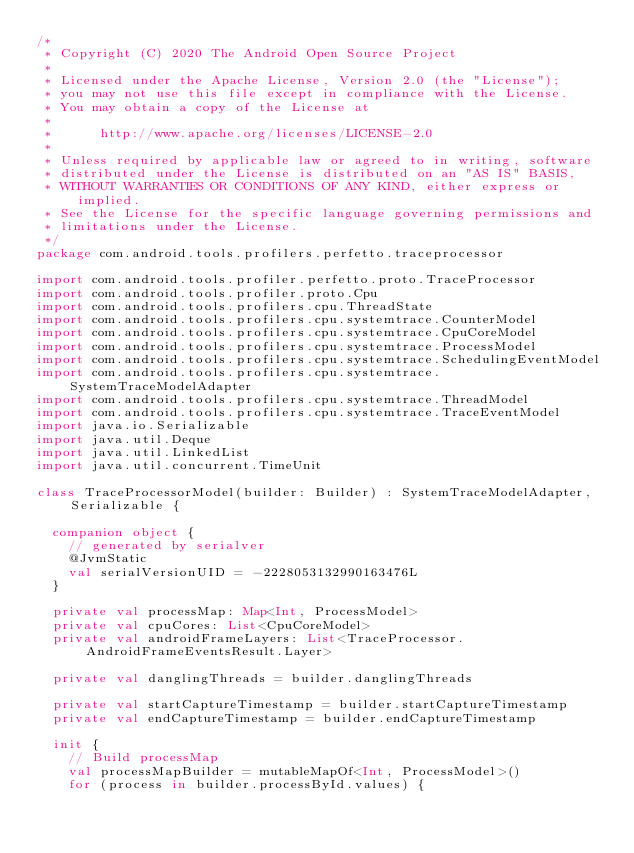<code> <loc_0><loc_0><loc_500><loc_500><_Kotlin_>/*
 * Copyright (C) 2020 The Android Open Source Project
 *
 * Licensed under the Apache License, Version 2.0 (the "License");
 * you may not use this file except in compliance with the License.
 * You may obtain a copy of the License at
 *
 *      http://www.apache.org/licenses/LICENSE-2.0
 *
 * Unless required by applicable law or agreed to in writing, software
 * distributed under the License is distributed on an "AS IS" BASIS,
 * WITHOUT WARRANTIES OR CONDITIONS OF ANY KIND, either express or implied.
 * See the License for the specific language governing permissions and
 * limitations under the License.
 */
package com.android.tools.profilers.perfetto.traceprocessor

import com.android.tools.profiler.perfetto.proto.TraceProcessor
import com.android.tools.profiler.proto.Cpu
import com.android.tools.profilers.cpu.ThreadState
import com.android.tools.profilers.cpu.systemtrace.CounterModel
import com.android.tools.profilers.cpu.systemtrace.CpuCoreModel
import com.android.tools.profilers.cpu.systemtrace.ProcessModel
import com.android.tools.profilers.cpu.systemtrace.SchedulingEventModel
import com.android.tools.profilers.cpu.systemtrace.SystemTraceModelAdapter
import com.android.tools.profilers.cpu.systemtrace.ThreadModel
import com.android.tools.profilers.cpu.systemtrace.TraceEventModel
import java.io.Serializable
import java.util.Deque
import java.util.LinkedList
import java.util.concurrent.TimeUnit

class TraceProcessorModel(builder: Builder) : SystemTraceModelAdapter, Serializable {

  companion object {
    // generated by serialver
    @JvmStatic
    val serialVersionUID = -2228053132990163476L
  }

  private val processMap: Map<Int, ProcessModel>
  private val cpuCores: List<CpuCoreModel>
  private val androidFrameLayers: List<TraceProcessor.AndroidFrameEventsResult.Layer>

  private val danglingThreads = builder.danglingThreads

  private val startCaptureTimestamp = builder.startCaptureTimestamp
  private val endCaptureTimestamp = builder.endCaptureTimestamp

  init {
    // Build processMap
    val processMapBuilder = mutableMapOf<Int, ProcessModel>()
    for (process in builder.processById.values) {</code> 